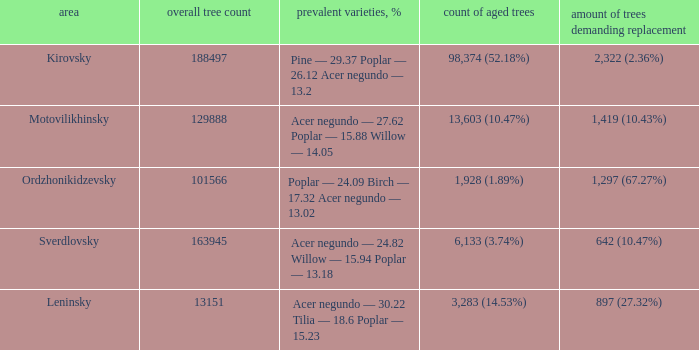What is the district when prevailing types, % is acer negundo — 30.22 tilia — 18.6 poplar — 15.23? Leninsky. 